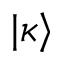<formula> <loc_0><loc_0><loc_500><loc_500>| \kappa \rangle</formula> 